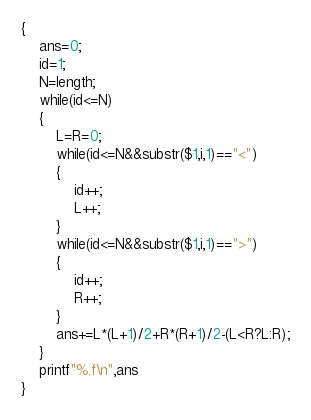<code> <loc_0><loc_0><loc_500><loc_500><_Awk_>{
	ans=0;
	id=1;
	N=length;
	while(id<=N)
	{
		L=R=0;
		while(id<=N&&substr($1,i,1)=="<")
		{
			id++;
			L++;
		}
		while(id<=N&&substr($1,i,1)==">")
		{
			id++;
			R++;
		}
		ans+=L*(L+1)/2+R*(R+1)/2-(L<R?L:R);
	}
	printf"%.f\n",ans
}
</code> 